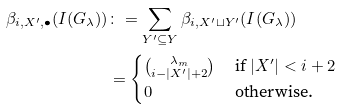<formula> <loc_0><loc_0><loc_500><loc_500>\beta _ { i , X ^ { \prime } , \bullet } ( I ( G _ { \lambda } ) ) & \colon = \sum _ { Y ^ { \prime } \subseteq Y } \beta _ { i , X ^ { \prime } \sqcup Y ^ { \prime } } ( I ( G _ { \lambda } ) ) \\ & = \begin{cases} \binom { \lambda _ { m } } { i - | X ^ { \prime } | + 2 } & \text { if } | X ^ { \prime } | < i + 2 \\ 0 & \text { otherwise.} \end{cases}</formula> 